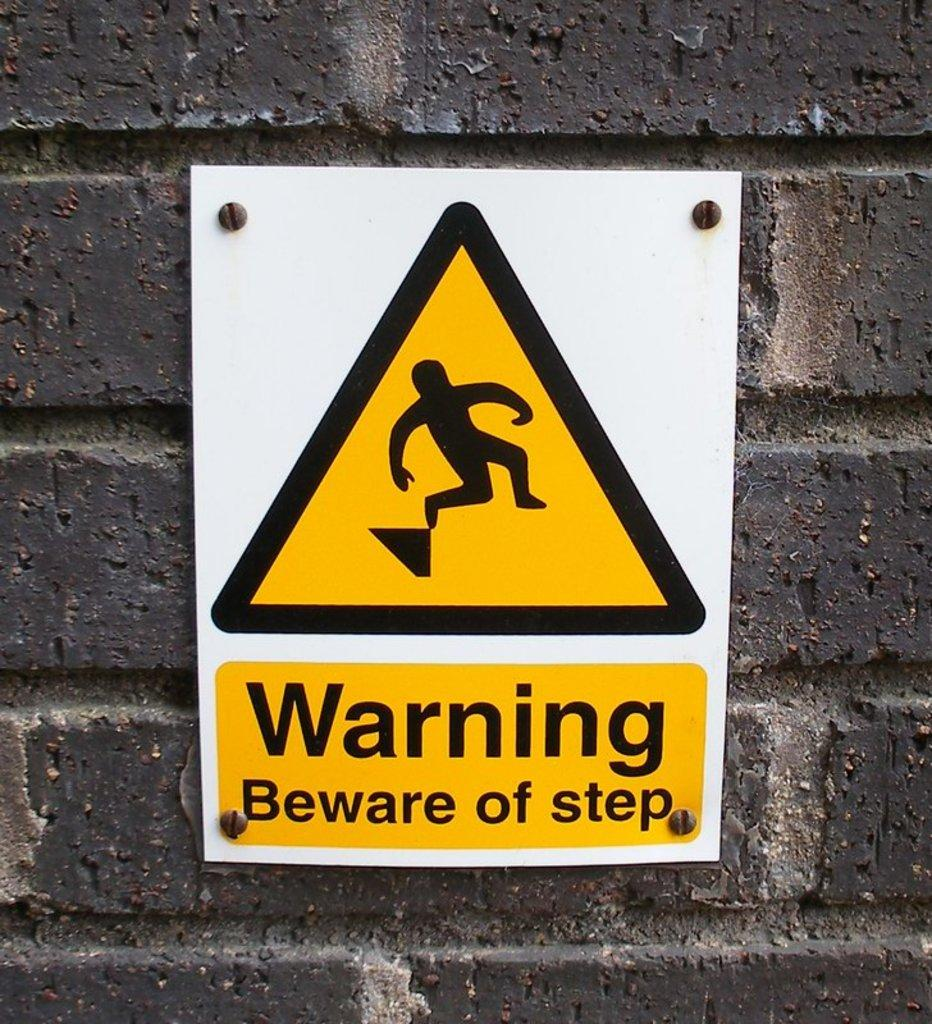Provide a one-sentence caption for the provided image. A warning sign that says to beware of step. 